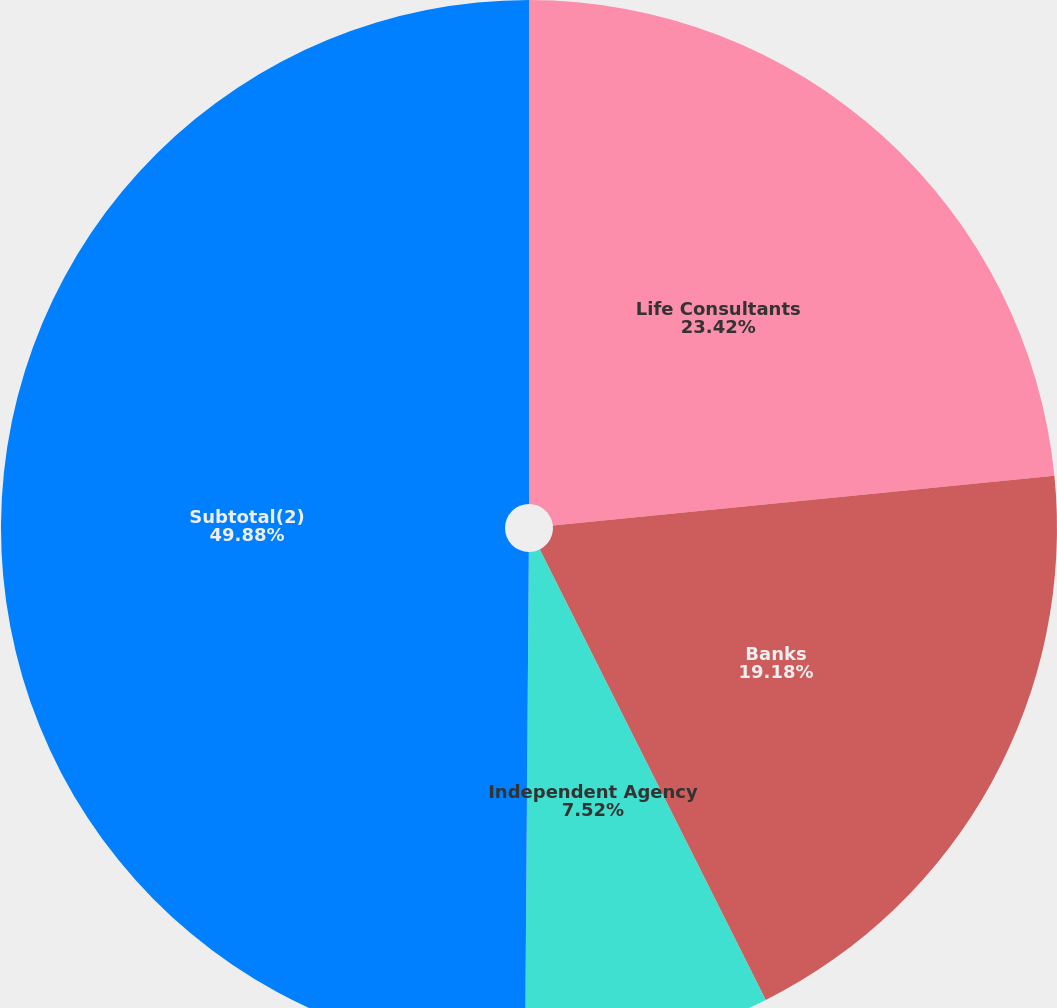Convert chart to OTSL. <chart><loc_0><loc_0><loc_500><loc_500><pie_chart><fcel>Life Consultants<fcel>Banks<fcel>Independent Agency<fcel>Subtotal(2)<nl><fcel>23.42%<fcel>19.18%<fcel>7.52%<fcel>49.88%<nl></chart> 